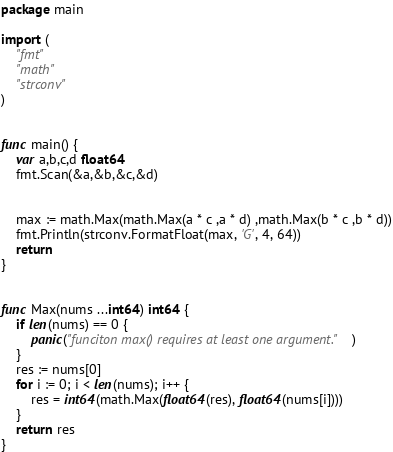Convert code to text. <code><loc_0><loc_0><loc_500><loc_500><_Go_>package main

import (
	"fmt"
	"math"
	"strconv"
)


func main() {
	var a,b,c,d float64
	fmt.Scan(&a,&b,&c,&d)


	max := math.Max(math.Max(a * c ,a * d) ,math.Max(b * c ,b * d))
	fmt.Println(strconv.FormatFloat(max, 'G', 4, 64)) 
	return
}


func Max(nums ...int64) int64 {
	if len(nums) == 0 {
		panic("funciton max() requires at least one argument.")
	}
	res := nums[0]
	for i := 0; i < len(nums); i++ {
		res = int64(math.Max(float64(res), float64(nums[i])))
	}
	return res
}
</code> 